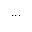Convert formula to latex. <formula><loc_0><loc_0><loc_500><loc_500>\dots</formula> 